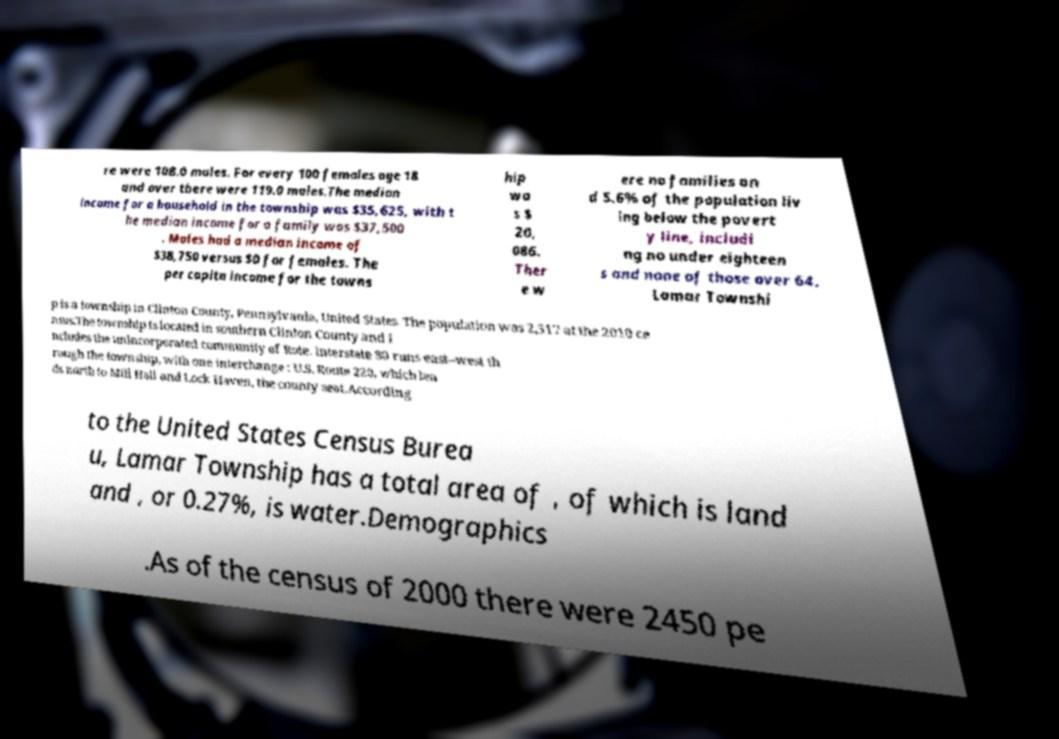Can you read and provide the text displayed in the image?This photo seems to have some interesting text. Can you extract and type it out for me? re were 108.0 males. For every 100 females age 18 and over there were 119.0 males.The median income for a household in the township was $35,625, with t he median income for a family was $37,500 . Males had a median income of $38,750 versus $0 for females. The per capita income for the towns hip wa s $ 20, 086. Ther e w ere no families an d 5.6% of the population liv ing below the povert y line, includi ng no under eighteen s and none of those over 64. Lamar Townshi p is a township in Clinton County, Pennsylvania, United States. The population was 2,517 at the 2010 ce nsus.The township is located in southern Clinton County and i ncludes the unincorporated community of Rote. Interstate 80 runs east–west th rough the township, with one interchange : U.S. Route 220, which lea ds north to Mill Hall and Lock Haven, the county seat.According to the United States Census Burea u, Lamar Township has a total area of , of which is land and , or 0.27%, is water.Demographics .As of the census of 2000 there were 2450 pe 